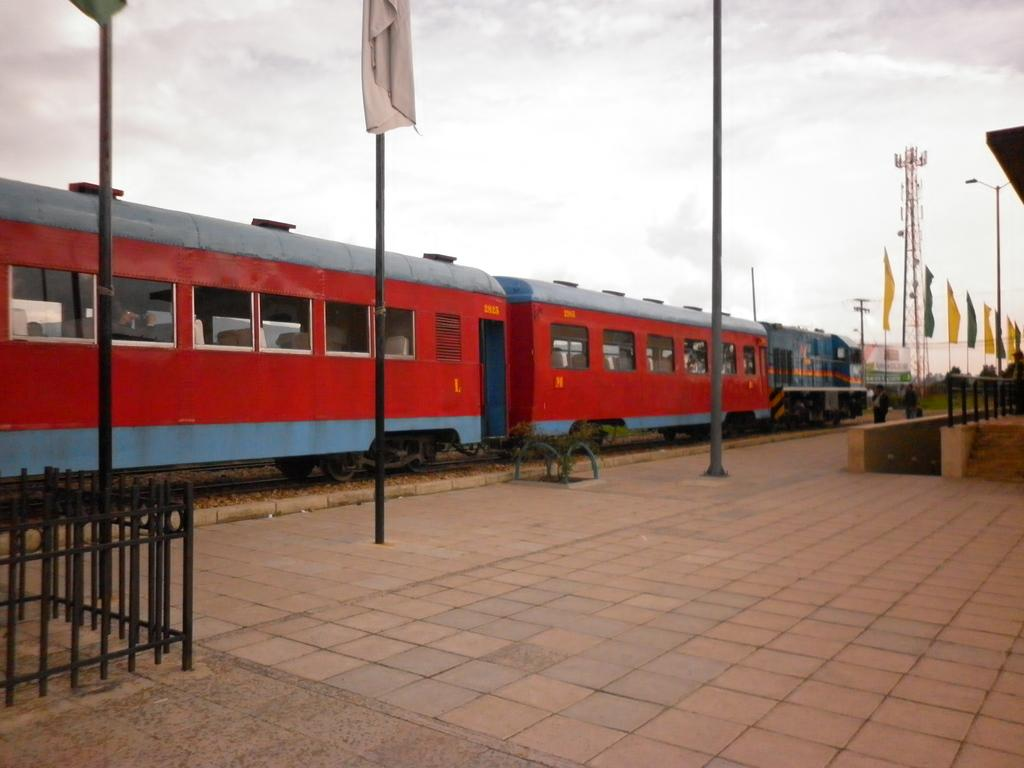What type of barriers can be seen in the image? There are fences in the image. What other structures are present in the image? There are poles and flags on the ground in the image. What is the main mode of transportation in the image? There is a train on a railway track in the image. What can be seen in the background of the image? There are trees, a building, and poles in the background of the image. What part of the natural environment is visible in the image? The sky is visible in the background of the image. What type of bean is being celebrated in the image? There is no bean or celebration present in the image. What color is the gold object in the image? There is no gold object present in the image. 